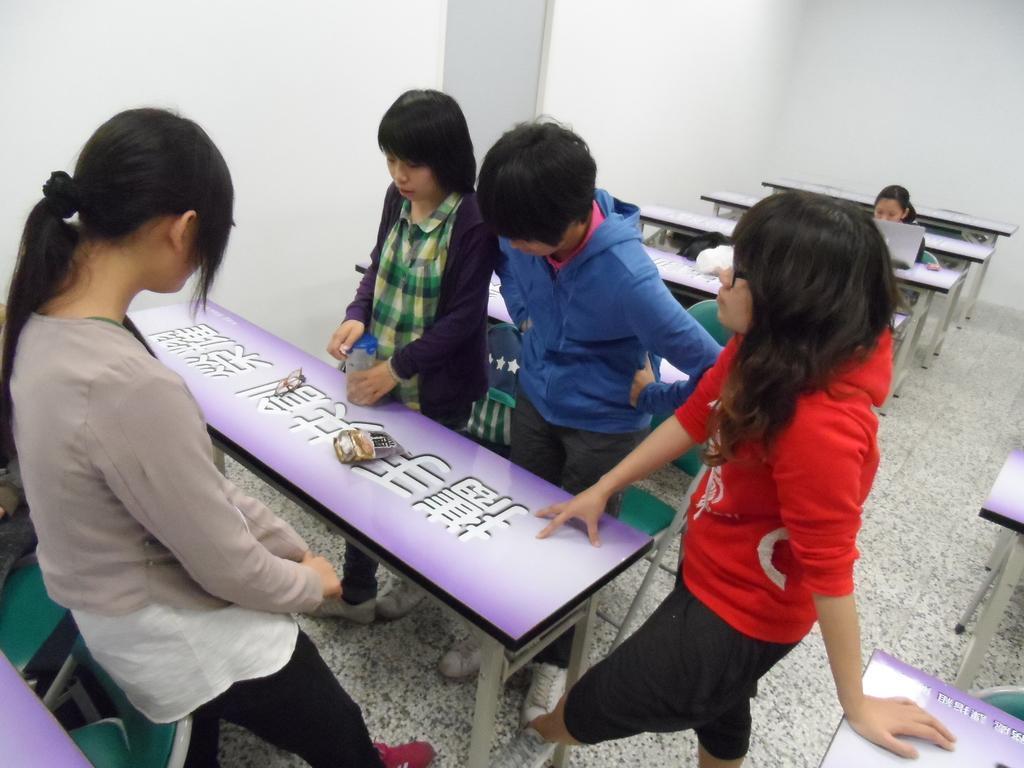In one or two sentences, can you explain what this image depicts? This is a room. In this room there are many tables and four are standing over there. And one girl wearing a violet jacket is holding a bottle. In the back there's a girl sitting with a laptop. And in the background there are walls. And a girl is wearing a red and black dress and she is having a spectacles. There are some items on this table. 